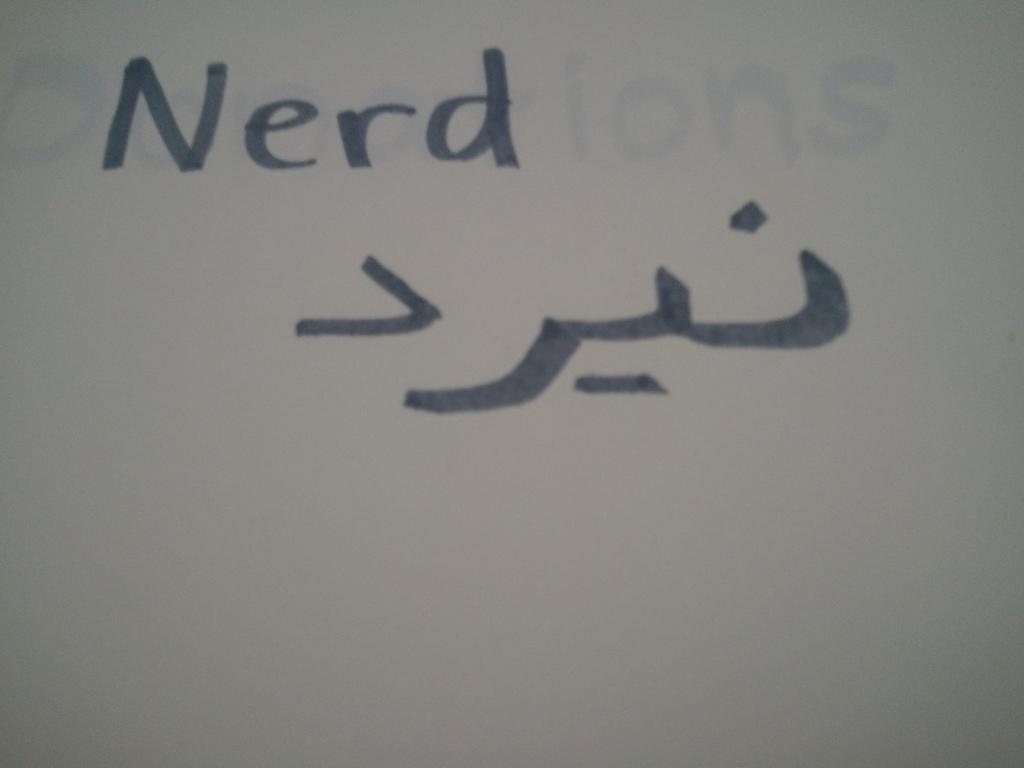<image>
Write a terse but informative summary of the picture. Written on a white board are the word "Nerd" and an Arabic or Persian word. 